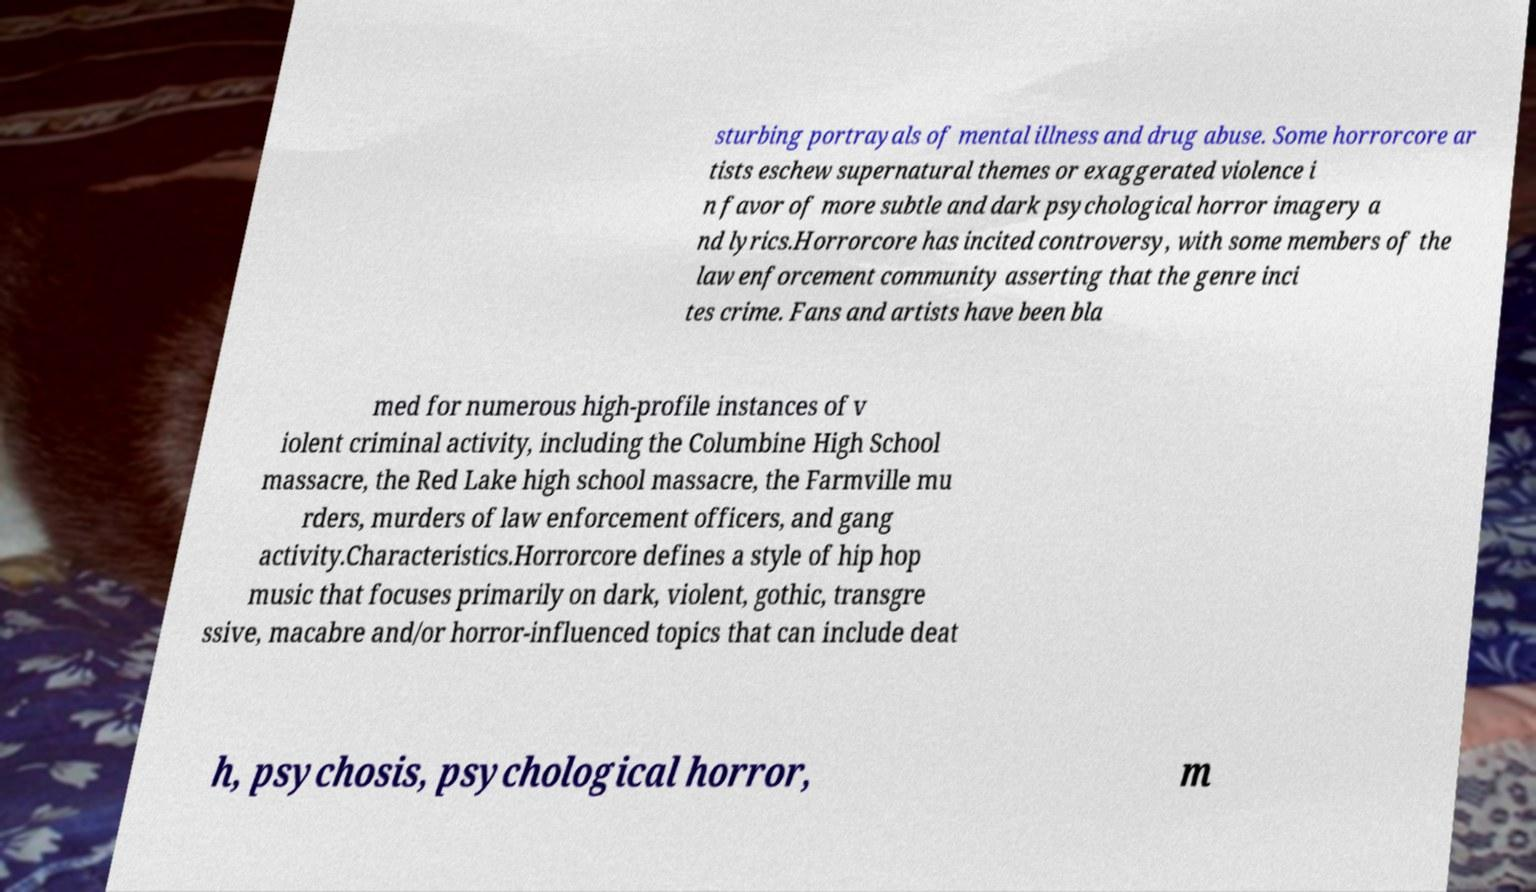Could you assist in decoding the text presented in this image and type it out clearly? sturbing portrayals of mental illness and drug abuse. Some horrorcore ar tists eschew supernatural themes or exaggerated violence i n favor of more subtle and dark psychological horror imagery a nd lyrics.Horrorcore has incited controversy, with some members of the law enforcement community asserting that the genre inci tes crime. Fans and artists have been bla med for numerous high-profile instances of v iolent criminal activity, including the Columbine High School massacre, the Red Lake high school massacre, the Farmville mu rders, murders of law enforcement officers, and gang activity.Characteristics.Horrorcore defines a style of hip hop music that focuses primarily on dark, violent, gothic, transgre ssive, macabre and/or horror-influenced topics that can include deat h, psychosis, psychological horror, m 